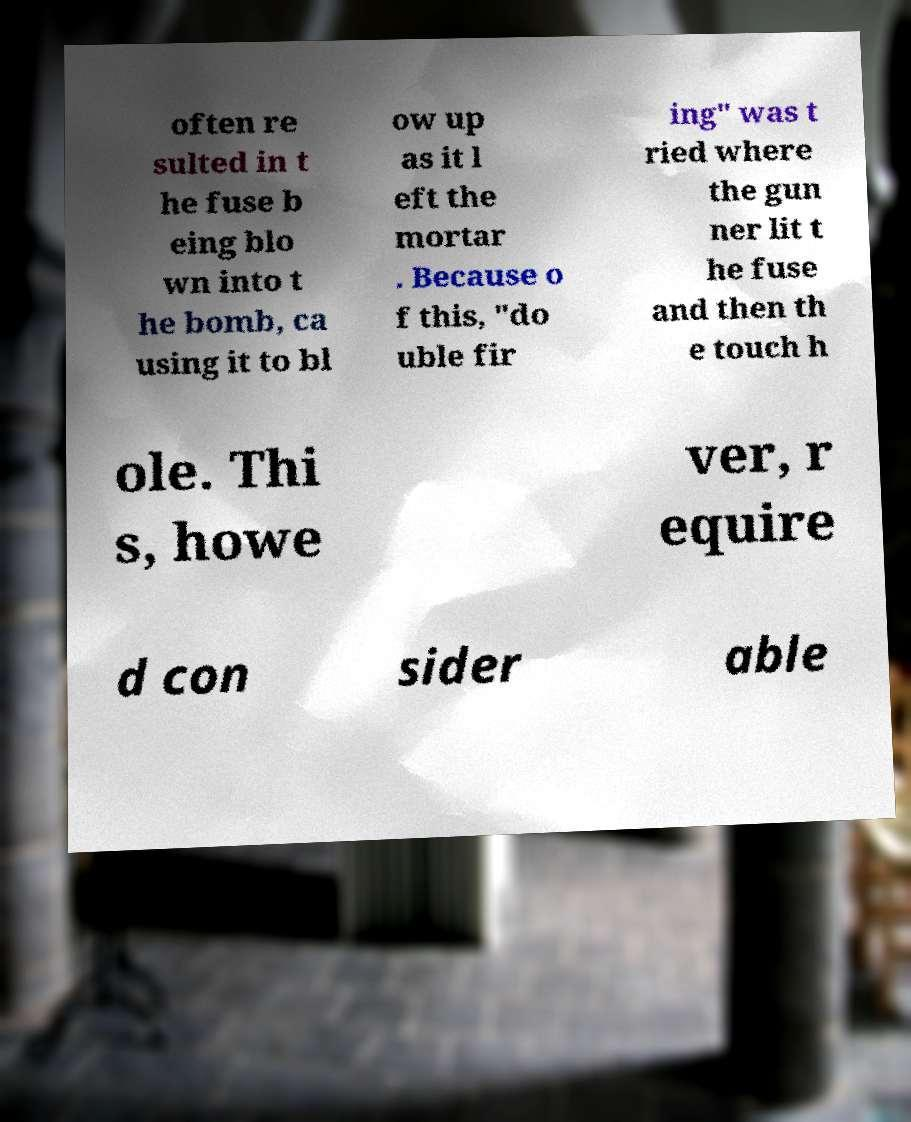What messages or text are displayed in this image? I need them in a readable, typed format. often re sulted in t he fuse b eing blo wn into t he bomb, ca using it to bl ow up as it l eft the mortar . Because o f this, "do uble fir ing" was t ried where the gun ner lit t he fuse and then th e touch h ole. Thi s, howe ver, r equire d con sider able 